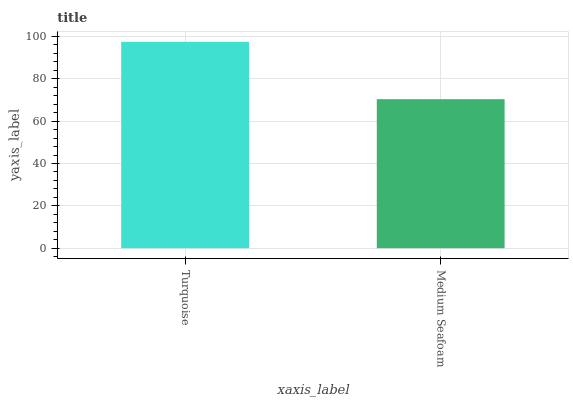Is Medium Seafoam the minimum?
Answer yes or no. Yes. Is Turquoise the maximum?
Answer yes or no. Yes. Is Medium Seafoam the maximum?
Answer yes or no. No. Is Turquoise greater than Medium Seafoam?
Answer yes or no. Yes. Is Medium Seafoam less than Turquoise?
Answer yes or no. Yes. Is Medium Seafoam greater than Turquoise?
Answer yes or no. No. Is Turquoise less than Medium Seafoam?
Answer yes or no. No. Is Turquoise the high median?
Answer yes or no. Yes. Is Medium Seafoam the low median?
Answer yes or no. Yes. Is Medium Seafoam the high median?
Answer yes or no. No. Is Turquoise the low median?
Answer yes or no. No. 